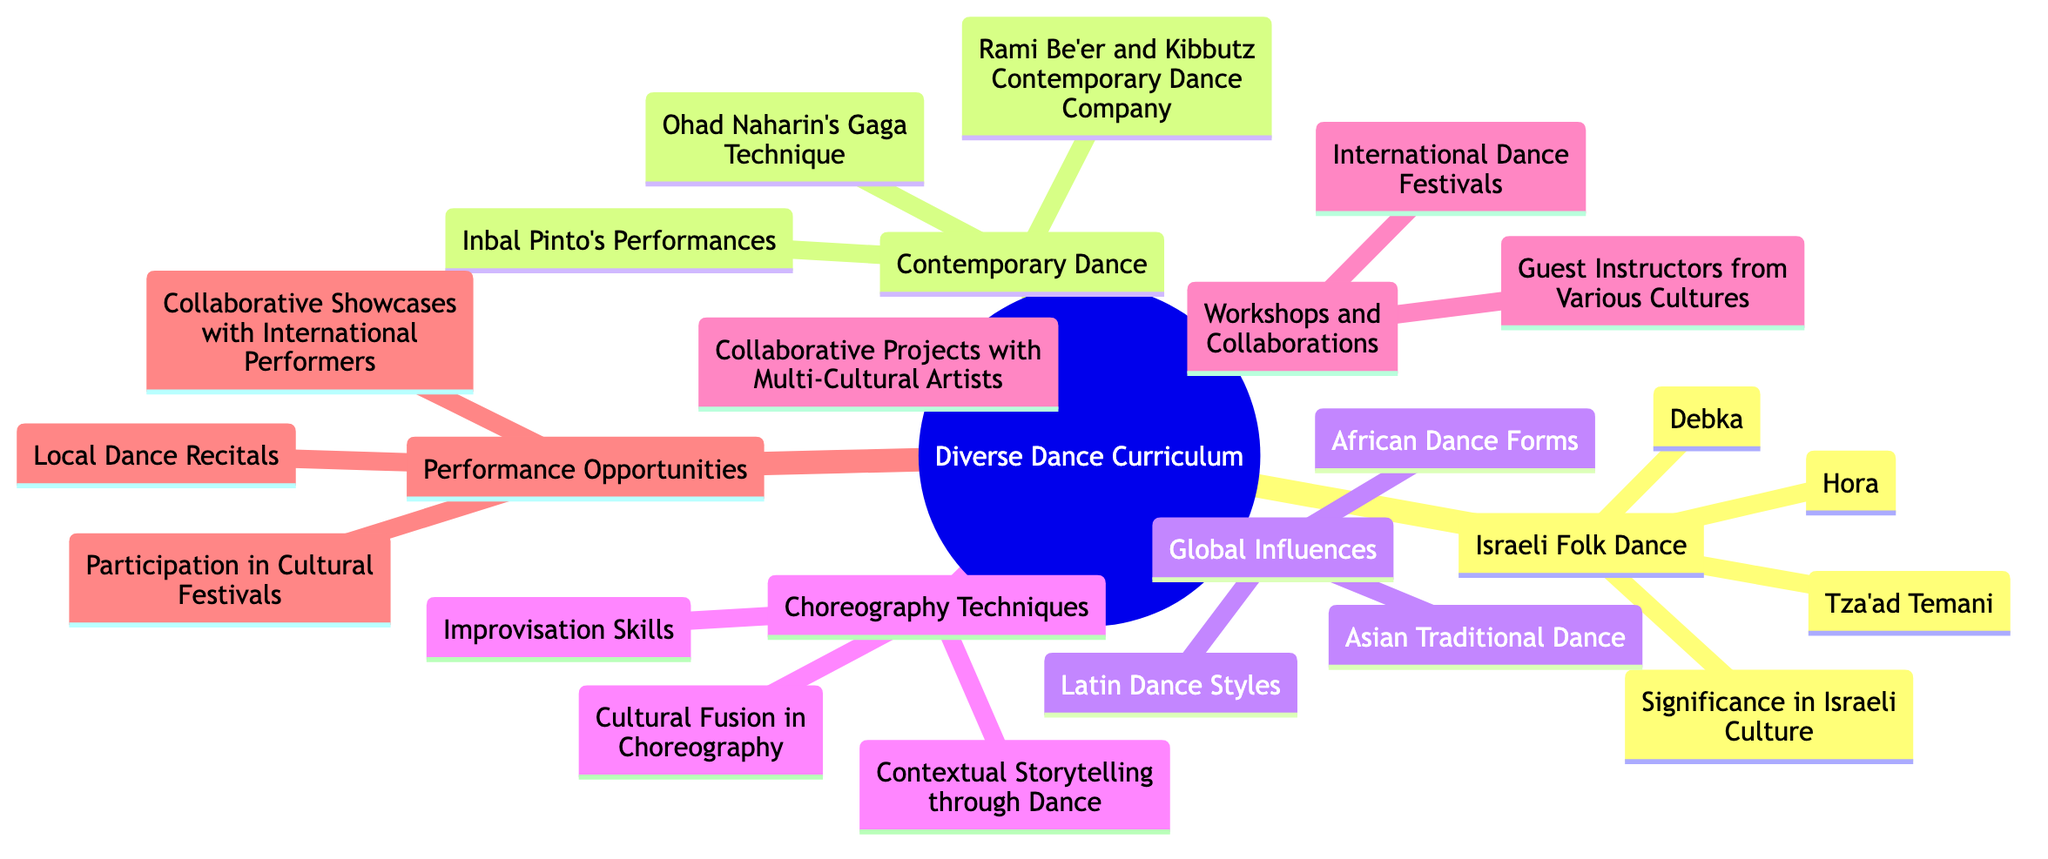What are the elements listed under Israeli Folk Dance? The diagram provides a sub-theme for Israeli Folk Dance, which includes four specific elements: Hora, Tza'ad Temani, Debka, and Significance in Israeli Culture.
Answer: Hora, Tza'ad Temani, Debka, Significance in Israeli Culture How many elements are listed under Global Influences? The Global Influences sub-theme has three distinct elements: African Dance Forms, Latin Dance Styles, and Asian Traditional Dance. Therefore, the count of elements is three.
Answer: 3 What is an example of a technique mentioned in Choreography Techniques? The Choreography Techniques sub-theme includes Improvisation Skills, Cultural Fusion in Choreography, and Contextual Storytelling through Dance. Hence, one example of a technique is Improvisation Skills.
Answer: Improvisation Skills Which contemporary choreographer is associated with Gaga Technique? Under the Contemporary Dance sub-theme, Ohad Naharin is directly linked to the Gaga Technique. Thus, the choreographer associated with it is Ohad Naharin.
Answer: Ohad Naharin Name one cultural festival where students can participate as per the Performance Opportunities node. The Performance Opportunities section lists several festivals, one of which is the Eilat Dance Festival. Hence, the students can participate in this festival.
Answer: Eilat Dance Festival How many sub-themes are present in the diagram? The central theme "Building a Diverse Dance Curriculum Incorporating Different Cultural Influences" branches out into six sub-themes: Israeli Folk Dance, Contemporary Dance, Global Influences, Choreography Techniques, Workshops and Collaborations, and Performance Opportunities. Therefore, the total number of sub-themes is six.
Answer: 6 What is a focus of the Workshops and Collaborations section? The Workshops and Collaborations sub-theme emphasizes engaging with Guest Instructors from Various Cultures, which indicates a focus on cultural diversity in dance education.
Answer: Guest Instructors from Various Cultures What kind of performances can be showcased according to the Performance Opportunities section? The Performance Opportunities specifically mention Collaborative Showcases with International Performers, indicating the type of performances that can be showcased.
Answer: Collaborative Showcases with International Performers Which dance styles are included in the Latin Dance Styles under Global Influences? While the Global Influences sub-theme mentions Latin Dance Styles, it includes specific examples like Salsa and Tango. Thus, two styles included are Salsa and Tango.
Answer: Salsa, Tango 